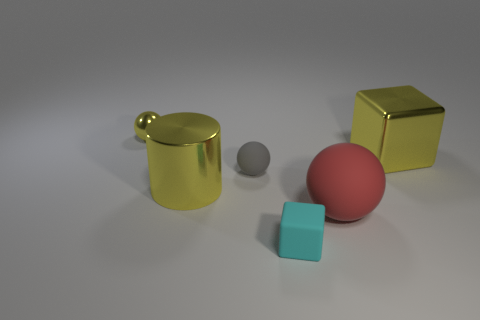Add 2 small cyan rubber cubes. How many objects exist? 8 Subtract all cylinders. How many objects are left? 5 Add 1 tiny cyan rubber blocks. How many tiny cyan rubber blocks are left? 2 Add 1 red rubber objects. How many red rubber objects exist? 2 Subtract 0 brown cylinders. How many objects are left? 6 Subtract all tiny rubber cubes. Subtract all small gray rubber balls. How many objects are left? 4 